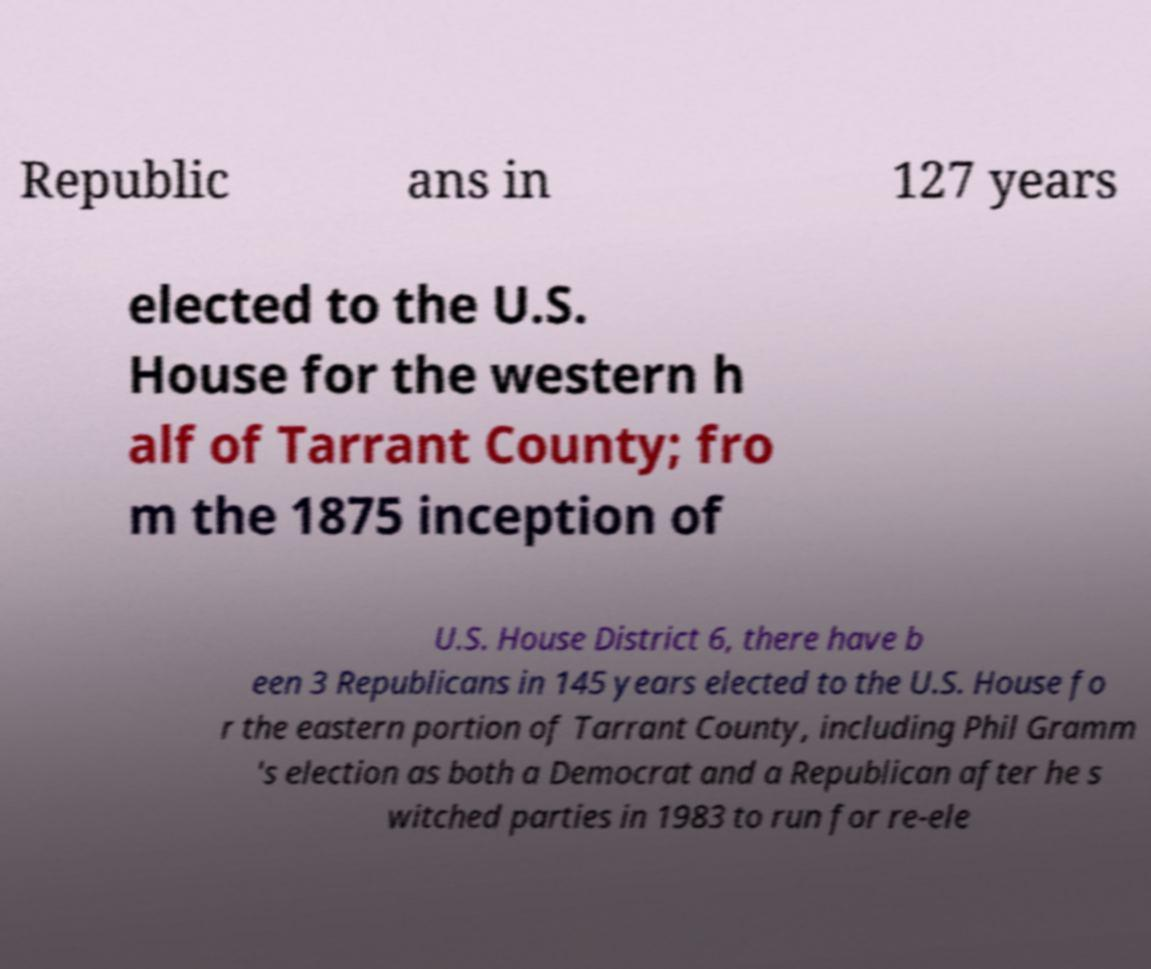I need the written content from this picture converted into text. Can you do that? Republic ans in 127 years elected to the U.S. House for the western h alf of Tarrant County; fro m the 1875 inception of U.S. House District 6, there have b een 3 Republicans in 145 years elected to the U.S. House fo r the eastern portion of Tarrant County, including Phil Gramm 's election as both a Democrat and a Republican after he s witched parties in 1983 to run for re-ele 